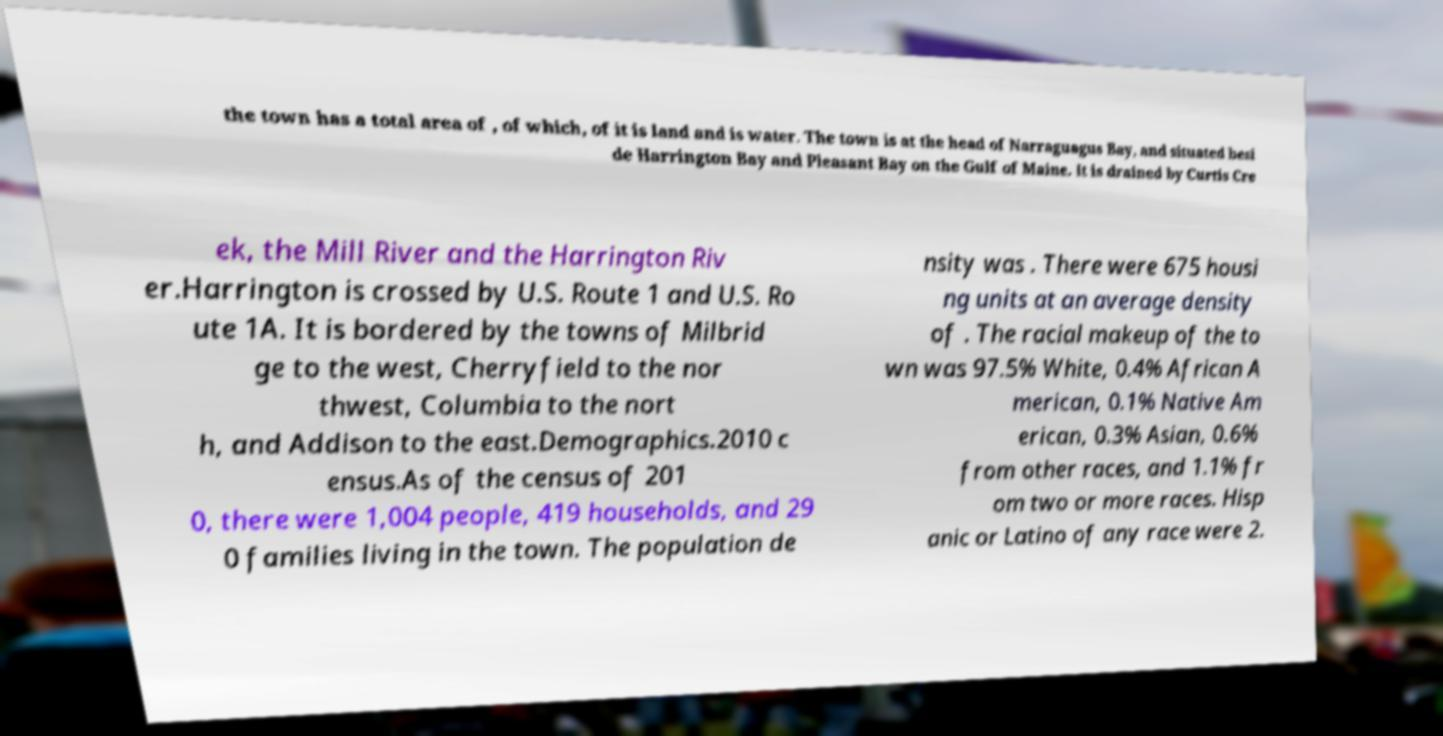There's text embedded in this image that I need extracted. Can you transcribe it verbatim? the town has a total area of , of which, of it is land and is water. The town is at the head of Narraguagus Bay, and situated besi de Harrington Bay and Pleasant Bay on the Gulf of Maine. It is drained by Curtis Cre ek, the Mill River and the Harrington Riv er.Harrington is crossed by U.S. Route 1 and U.S. Ro ute 1A. It is bordered by the towns of Milbrid ge to the west, Cherryfield to the nor thwest, Columbia to the nort h, and Addison to the east.Demographics.2010 c ensus.As of the census of 201 0, there were 1,004 people, 419 households, and 29 0 families living in the town. The population de nsity was . There were 675 housi ng units at an average density of . The racial makeup of the to wn was 97.5% White, 0.4% African A merican, 0.1% Native Am erican, 0.3% Asian, 0.6% from other races, and 1.1% fr om two or more races. Hisp anic or Latino of any race were 2. 